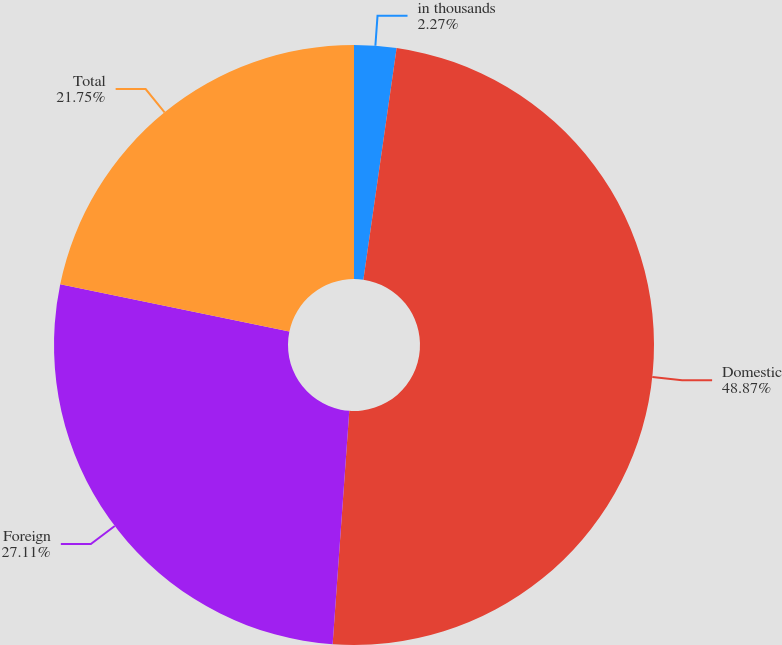Convert chart to OTSL. <chart><loc_0><loc_0><loc_500><loc_500><pie_chart><fcel>in thousands<fcel>Domestic<fcel>Foreign<fcel>Total<nl><fcel>2.27%<fcel>48.86%<fcel>27.11%<fcel>21.75%<nl></chart> 